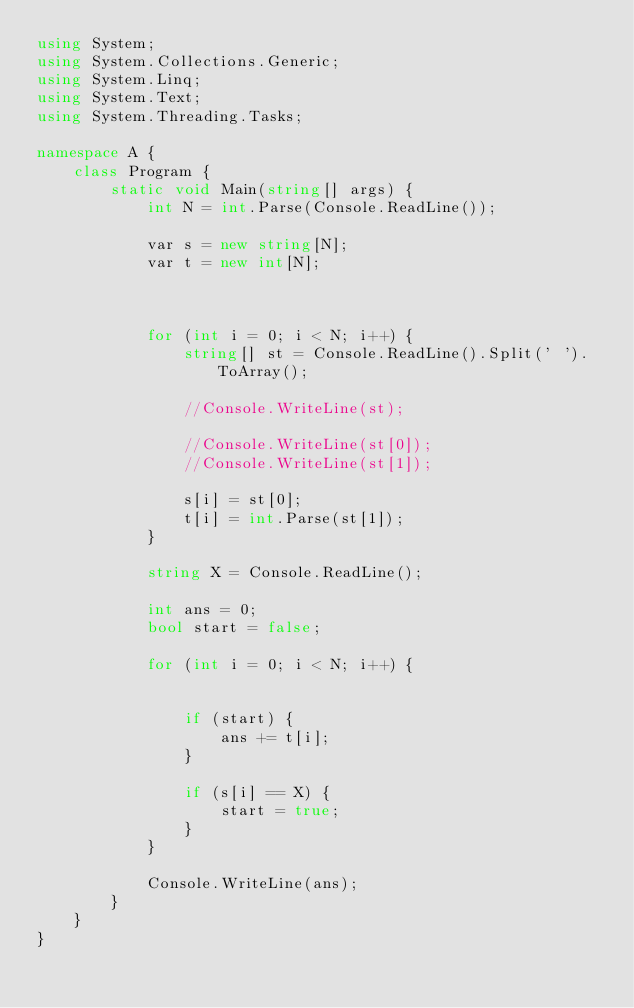<code> <loc_0><loc_0><loc_500><loc_500><_C#_>using System;
using System.Collections.Generic;
using System.Linq;
using System.Text;
using System.Threading.Tasks;

namespace A {
    class Program {
        static void Main(string[] args) {
            int N = int.Parse(Console.ReadLine());

            var s = new string[N];
            var t = new int[N];

            

            for (int i = 0; i < N; i++) {
                string[] st = Console.ReadLine().Split(' ').ToArray();

                //Console.WriteLine(st);

                //Console.WriteLine(st[0]);
                //Console.WriteLine(st[1]);

                s[i] = st[0];
                t[i] = int.Parse(st[1]);
            }

            string X = Console.ReadLine();

            int ans = 0;
            bool start = false;

            for (int i = 0; i < N; i++) {
                

                if (start) {
                    ans += t[i];
                }

                if (s[i] == X) {
                    start = true;
                }
            }

            Console.WriteLine(ans);
        }
    }
}
</code> 